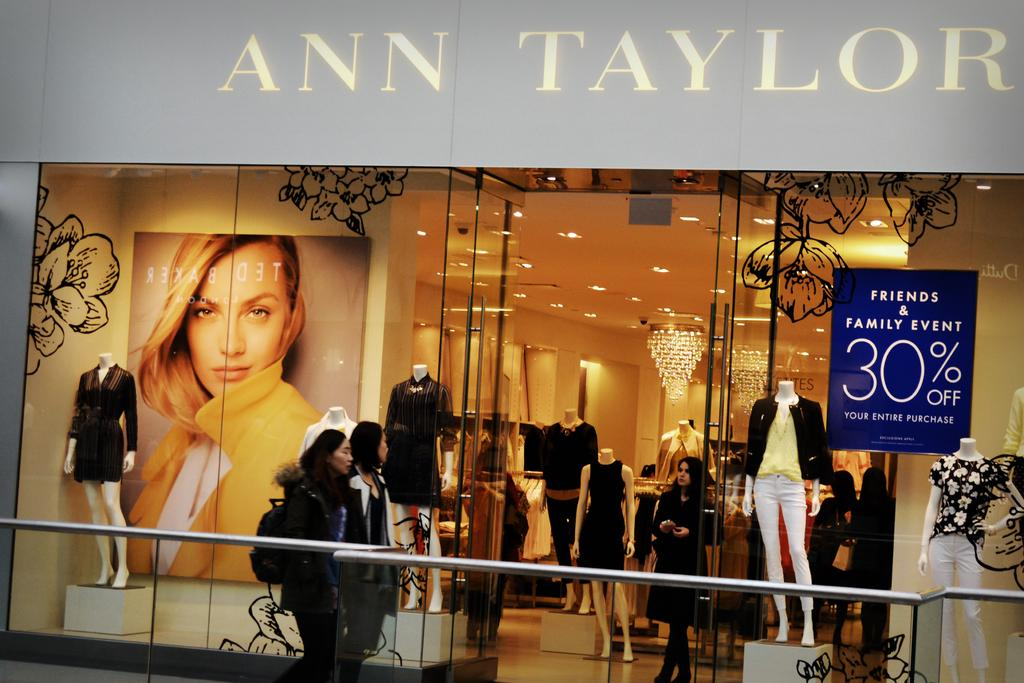What are the people in the image doing? The people in the image are on the floor. What else can be seen in the image besides people? There are mannequins, clothes, lights, a wall, and other objects in the image. What might the mannequins be used for? The mannequins might be used for displaying clothes. Can you describe the lighting in the image? Lights are visible in the image. How does the root of the tree contribute to the quiet atmosphere in the image? There is no tree or quiet atmosphere mentioned in the image; it features people, mannequins, clothes, lights, a wall, and other objects. 